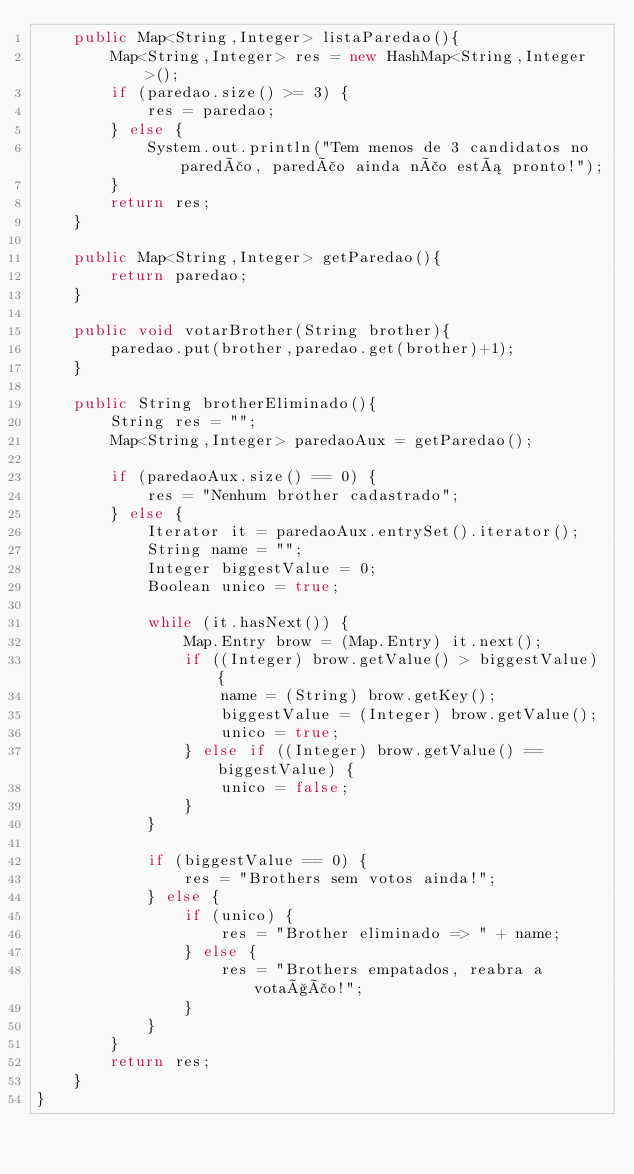Convert code to text. <code><loc_0><loc_0><loc_500><loc_500><_Java_>    public Map<String,Integer> listaParedao(){
        Map<String,Integer> res = new HashMap<String,Integer>();
        if (paredao.size() >= 3) {
            res = paredao;
        } else {
            System.out.println("Tem menos de 3 candidatos no paredão, paredão ainda não está pronto!");
        }
        return res;
    }

    public Map<String,Integer> getParedao(){
        return paredao;
    }

    public void votarBrother(String brother){
        paredao.put(brother,paredao.get(brother)+1);
    }

    public String brotherEliminado(){
        String res = "";
        Map<String,Integer> paredaoAux = getParedao();

        if (paredaoAux.size() == 0) {
            res = "Nenhum brother cadastrado";
        } else {
            Iterator it = paredaoAux.entrySet().iterator();
            String name = "";
            Integer biggestValue = 0;
            Boolean unico = true;

            while (it.hasNext()) {
                Map.Entry brow = (Map.Entry) it.next();
                if ((Integer) brow.getValue() > biggestValue) {
                    name = (String) brow.getKey();
                    biggestValue = (Integer) brow.getValue();
                    unico = true;
                } else if ((Integer) brow.getValue() == biggestValue) {
                    unico = false;
                }
            }

            if (biggestValue == 0) {
                res = "Brothers sem votos ainda!";
            } else {
                if (unico) {
                    res = "Brother eliminado => " + name;
                } else {
                    res = "Brothers empatados, reabra a votação!";
                }
            }
        }
        return res;
    }
}
</code> 